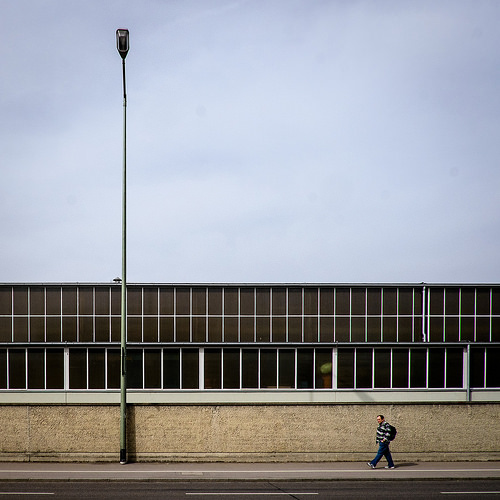<image>
Is there a light in front of the person? Yes. The light is positioned in front of the person, appearing closer to the camera viewpoint. 